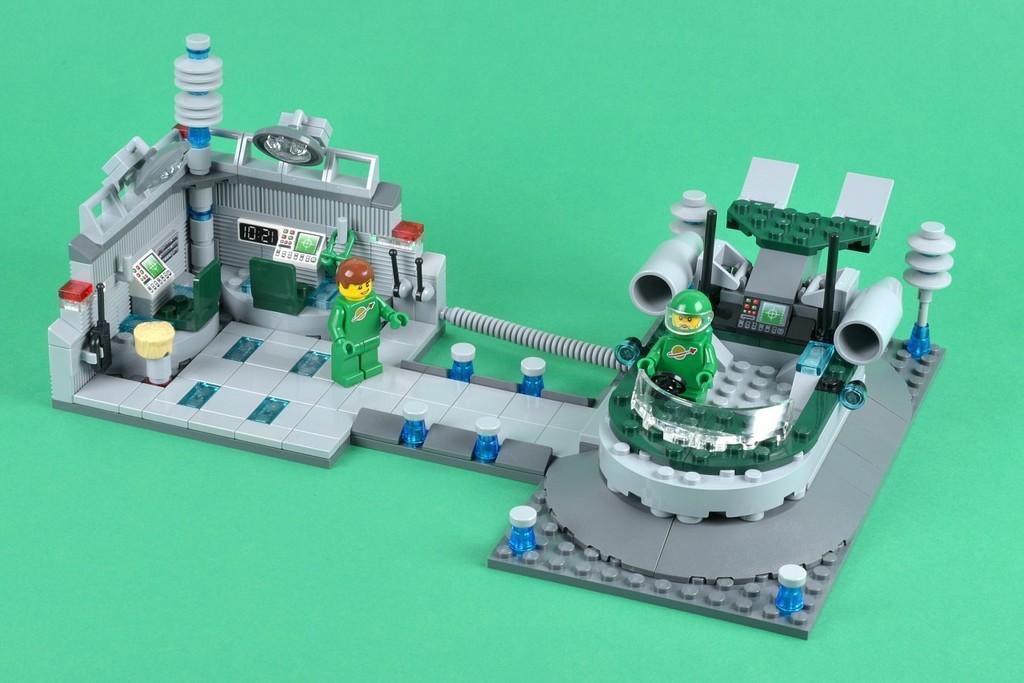Can you describe this image briefly? In this image there are few toys on the floor which is in green color. 